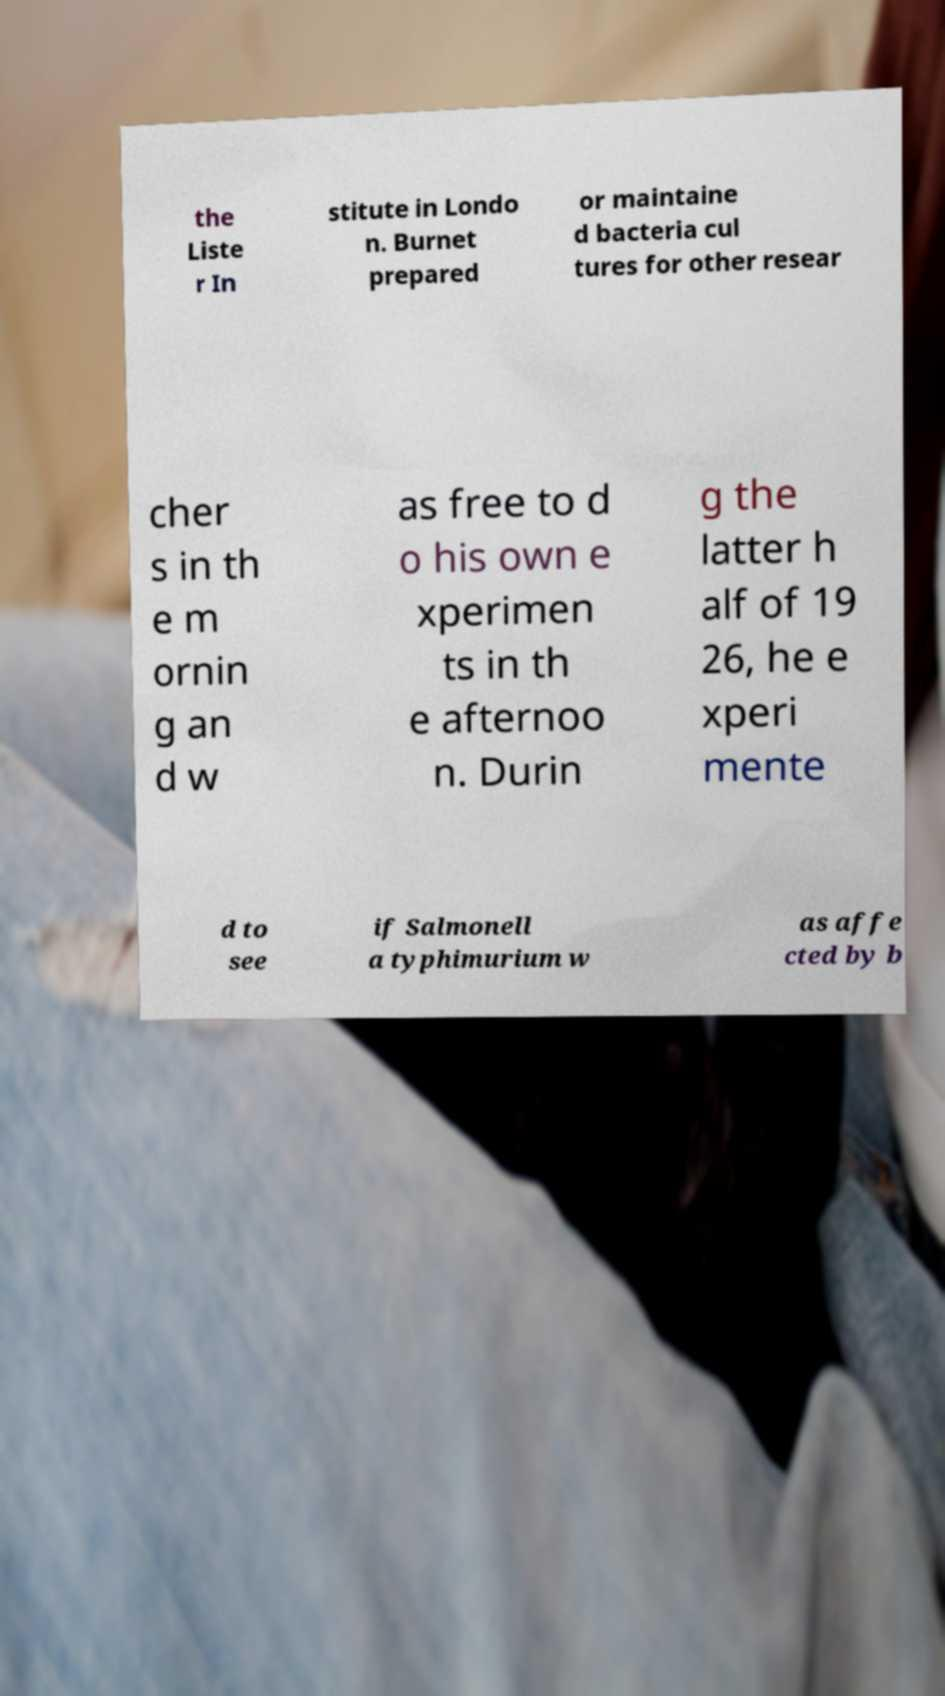Please identify and transcribe the text found in this image. the Liste r In stitute in Londo n. Burnet prepared or maintaine d bacteria cul tures for other resear cher s in th e m ornin g an d w as free to d o his own e xperimen ts in th e afternoo n. Durin g the latter h alf of 19 26, he e xperi mente d to see if Salmonell a typhimurium w as affe cted by b 